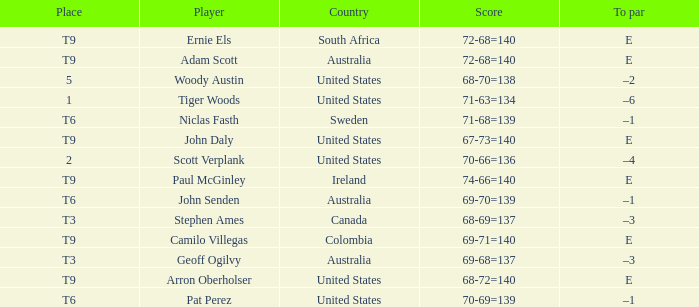Which country has a score of 70-66=136? United States. Would you be able to parse every entry in this table? {'header': ['Place', 'Player', 'Country', 'Score', 'To par'], 'rows': [['T9', 'Ernie Els', 'South Africa', '72-68=140', 'E'], ['T9', 'Adam Scott', 'Australia', '72-68=140', 'E'], ['5', 'Woody Austin', 'United States', '68-70=138', '–2'], ['1', 'Tiger Woods', 'United States', '71-63=134', '–6'], ['T6', 'Niclas Fasth', 'Sweden', '71-68=139', '–1'], ['T9', 'John Daly', 'United States', '67-73=140', 'E'], ['2', 'Scott Verplank', 'United States', '70-66=136', '–4'], ['T9', 'Paul McGinley', 'Ireland', '74-66=140', 'E'], ['T6', 'John Senden', 'Australia', '69-70=139', '–1'], ['T3', 'Stephen Ames', 'Canada', '68-69=137', '–3'], ['T9', 'Camilo Villegas', 'Colombia', '69-71=140', 'E'], ['T3', 'Geoff Ogilvy', 'Australia', '69-68=137', '–3'], ['T9', 'Arron Oberholser', 'United States', '68-72=140', 'E'], ['T6', 'Pat Perez', 'United States', '70-69=139', '–1']]} 